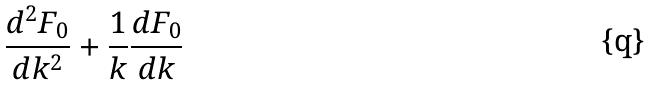<formula> <loc_0><loc_0><loc_500><loc_500>\frac { d ^ { 2 } F _ { 0 } } { d k ^ { 2 } } + \frac { 1 } { k } \frac { d F _ { 0 } } { d k }</formula> 